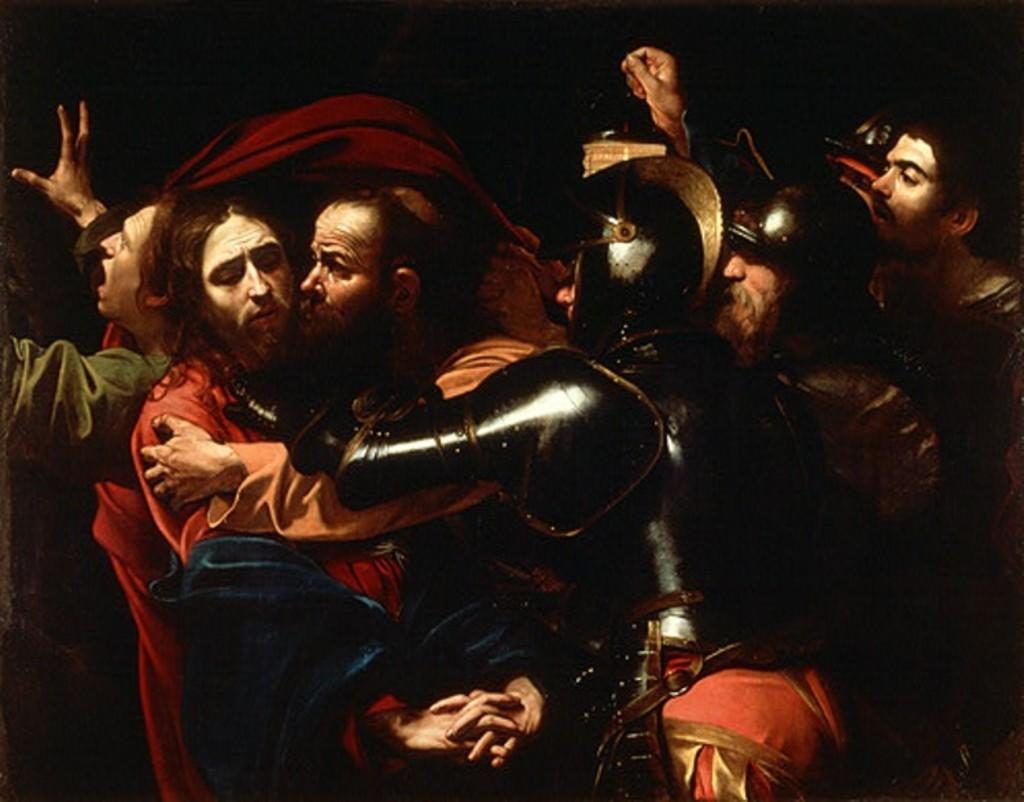What is the main subject of the image? The main subject of the image is a group of men. Can you describe the appearance of some of the men in the group? Three men in the group are wearing helmets. What can be observed about the background of the image? The background of the image is dark. What type of bait is being used by the men in the image? There is no indication of fishing or bait in the image; it features a group of men, some of whom are wearing helmets. Can you see any flowers in the image? There are no flowers present in the image. 